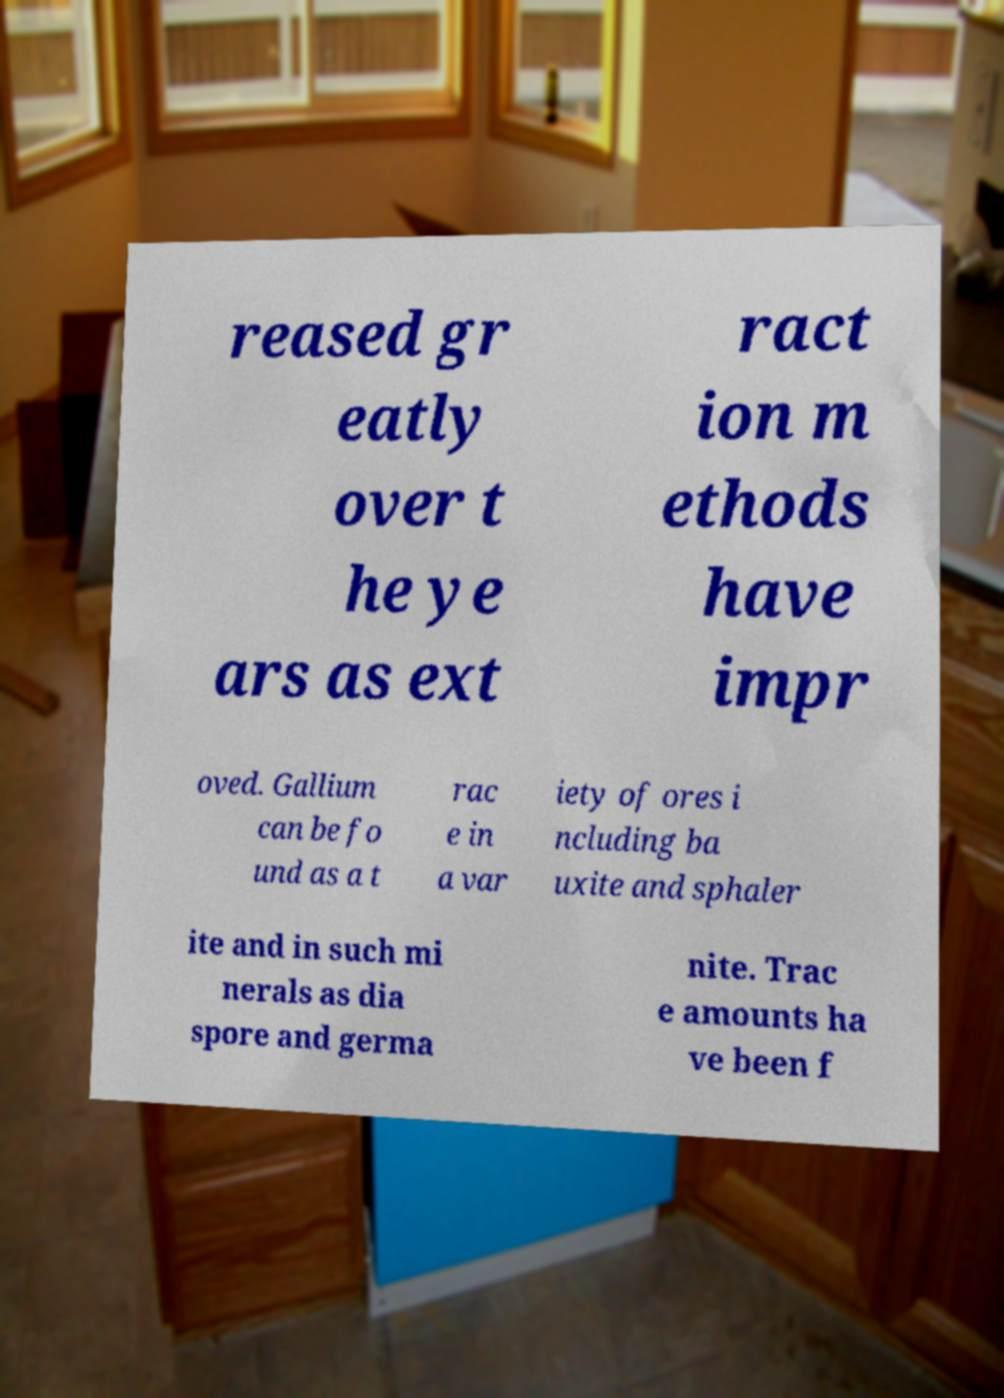For documentation purposes, I need the text within this image transcribed. Could you provide that? reased gr eatly over t he ye ars as ext ract ion m ethods have impr oved. Gallium can be fo und as a t rac e in a var iety of ores i ncluding ba uxite and sphaler ite and in such mi nerals as dia spore and germa nite. Trac e amounts ha ve been f 